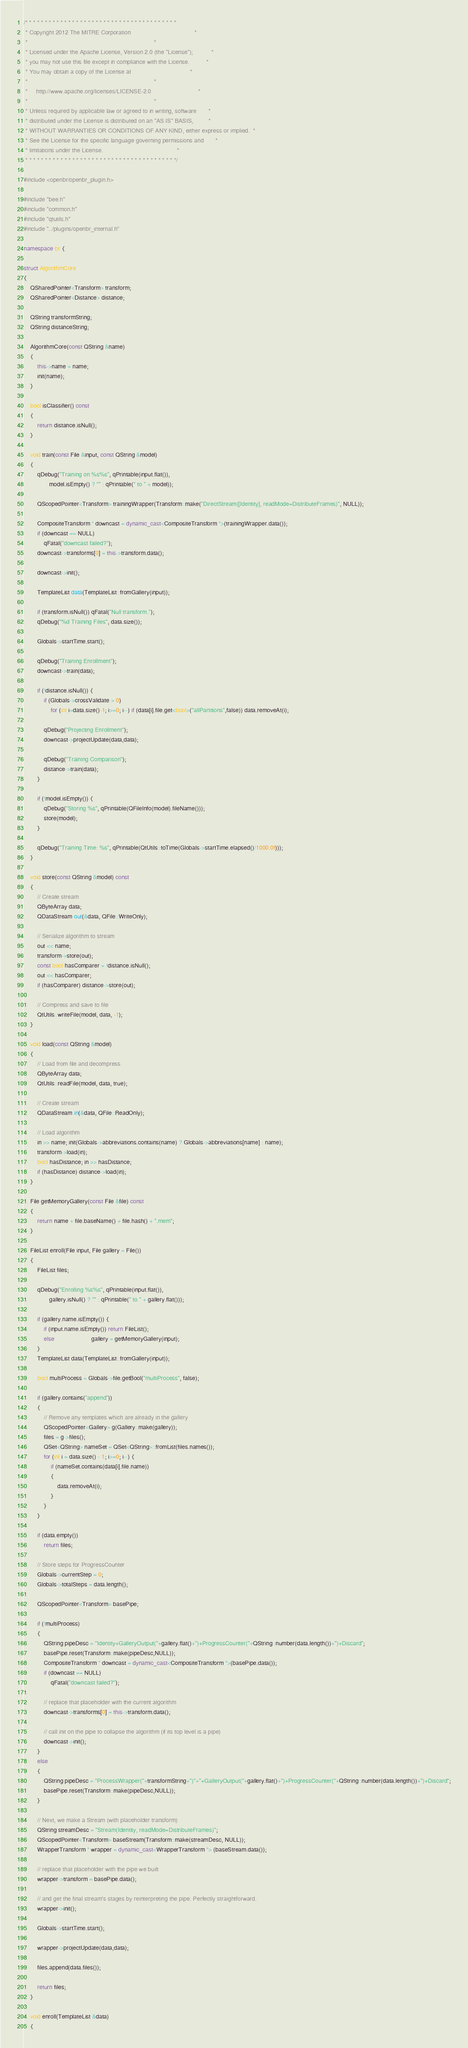Convert code to text. <code><loc_0><loc_0><loc_500><loc_500><_C++_>/* * * * * * * * * * * * * * * * * * * * * * * * * * * * * * * * * * * * * * *
 * Copyright 2012 The MITRE Corporation                                      *
 *                                                                           *
 * Licensed under the Apache License, Version 2.0 (the "License");           *
 * you may not use this file except in compliance with the License.          *
 * You may obtain a copy of the License at                                   *
 *                                                                           *
 *     http://www.apache.org/licenses/LICENSE-2.0                            *
 *                                                                           *
 * Unless required by applicable law or agreed to in writing, software       *
 * distributed under the License is distributed on an "AS IS" BASIS,         *
 * WITHOUT WARRANTIES OR CONDITIONS OF ANY KIND, either express or implied.  *
 * See the License for the specific language governing permissions and       *
 * limitations under the License.                                            *
 * * * * * * * * * * * * * * * * * * * * * * * * * * * * * * * * * * * * * * */

#include <openbr/openbr_plugin.h>

#include "bee.h"
#include "common.h"
#include "qtutils.h"
#include "../plugins/openbr_internal.h"

namespace br {

struct AlgorithmCore
{
    QSharedPointer<Transform> transform;
    QSharedPointer<Distance> distance;

    QString transformString;
    QString distanceString;

    AlgorithmCore(const QString &name)
    {
        this->name = name;
        init(name);
    }

    bool isClassifier() const
    {
        return distance.isNull();
    }

    void train(const File &input, const QString &model)
    {
        qDebug("Training on %s%s", qPrintable(input.flat()),
               model.isEmpty() ? "" : qPrintable(" to " + model));

        QScopedPointer<Transform> trainingWrapper(Transform::make("DirectStream([Identity], readMode=DistributeFrames)", NULL));

        CompositeTransform * downcast = dynamic_cast<CompositeTransform *>(trainingWrapper.data());
        if (downcast == NULL)
            qFatal("downcast failed?");
        downcast->transforms[0] = this->transform.data();

        downcast->init();

        TemplateList data(TemplateList::fromGallery(input));

        if (transform.isNull()) qFatal("Null transform.");
        qDebug("%d Training Files", data.size());

        Globals->startTime.start();

        qDebug("Training Enrollment");
        downcast->train(data);

        if (!distance.isNull()) {
            if (Globals->crossValidate > 0)
                for (int i=data.size()-1; i>=0; i--) if (data[i].file.get<bool>("allPartitions",false)) data.removeAt(i);

            qDebug("Projecting Enrollment");
            downcast->projectUpdate(data,data);

            qDebug("Training Comparison");
            distance->train(data);
        }

        if (!model.isEmpty()) {
            qDebug("Storing %s", qPrintable(QFileInfo(model).fileName()));
            store(model);
        }

        qDebug("Training Time: %s", qPrintable(QtUtils::toTime(Globals->startTime.elapsed()/1000.0f)));
    }

    void store(const QString &model) const
    {
        // Create stream
        QByteArray data;
        QDataStream out(&data, QFile::WriteOnly);

        // Serialize algorithm to stream
        out << name;
        transform->store(out);
        const bool hasComparer = !distance.isNull();
        out << hasComparer;
        if (hasComparer) distance->store(out);

        // Compress and save to file
        QtUtils::writeFile(model, data, -1);
    }

    void load(const QString &model)
    {
        // Load from file and decompress
        QByteArray data;
        QtUtils::readFile(model, data, true);

        // Create stream
        QDataStream in(&data, QFile::ReadOnly);

        // Load algorithm
        in >> name; init(Globals->abbreviations.contains(name) ? Globals->abbreviations[name] : name);
        transform->load(in);
        bool hasDistance; in >> hasDistance;
        if (hasDistance) distance->load(in);
    }

    File getMemoryGallery(const File &file) const
    {
        return name + file.baseName() + file.hash() + ".mem";
    }

    FileList enroll(File input, File gallery = File())
    {
        FileList files;

        qDebug("Enrolling %s%s", qPrintable(input.flat()),
               gallery.isNull() ? "" : qPrintable(" to " + gallery.flat()));

        if (gallery.name.isEmpty()) {
            if (input.name.isEmpty()) return FileList();
            else                      gallery = getMemoryGallery(input);
        }
        TemplateList data(TemplateList::fromGallery(input));

        bool multiProcess = Globals->file.getBool("multiProcess", false);

        if (gallery.contains("append"))
        {
            // Remove any templates which are already in the gallery
            QScopedPointer<Gallery> g(Gallery::make(gallery));
            files = g->files();
            QSet<QString> nameSet = QSet<QString>::fromList(files.names());
            for (int i = data.size() - 1; i>=0; i--) {
                if (nameSet.contains(data[i].file.name))
                {
                    data.removeAt(i);
                }
            }
        }

        if (data.empty())
            return files;

        // Store steps for ProgressCounter
        Globals->currentStep = 0;
        Globals->totalSteps = data.length();

        QScopedPointer<Transform> basePipe;

        if (!multiProcess)
        {
            QString pipeDesc = "Identity+GalleryOutput("+gallery.flat()+")+ProgressCounter("+QString::number(data.length())+")+Discard";
            basePipe.reset(Transform::make(pipeDesc,NULL));
            CompositeTransform * downcast = dynamic_cast<CompositeTransform *>(basePipe.data());
            if (downcast == NULL)
                qFatal("downcast failed?");

            // replace that placeholder with the current algorithm
            downcast->transforms[0] = this->transform.data();

            // call init on the pipe to collapse the algorithm (if its top level is a pipe)
            downcast->init();
        }
        else
        {
            QString pipeDesc = "ProcessWrapper("+transformString+")"+"+GalleryOutput("+gallery.flat()+")+ProgressCounter("+QString::number(data.length())+")+Discard";
            basePipe.reset(Transform::make(pipeDesc,NULL));
        }

        // Next, we make a Stream (with placeholder transform)
        QString streamDesc = "Stream(Identity, readMode=DistributeFrames)";
        QScopedPointer<Transform> baseStream(Transform::make(streamDesc, NULL));
        WrapperTransform * wrapper = dynamic_cast<WrapperTransform *> (baseStream.data());

        // replace that placeholder with the pipe we built
        wrapper->transform = basePipe.data();

        // and get the final stream's stages by reinterpreting the pipe. Perfectly straightforward.
        wrapper->init();

        Globals->startTime.start();

        wrapper->projectUpdate(data,data);

        files.append(data.files());

        return files;
    }

    void enroll(TemplateList &data)
    {</code> 